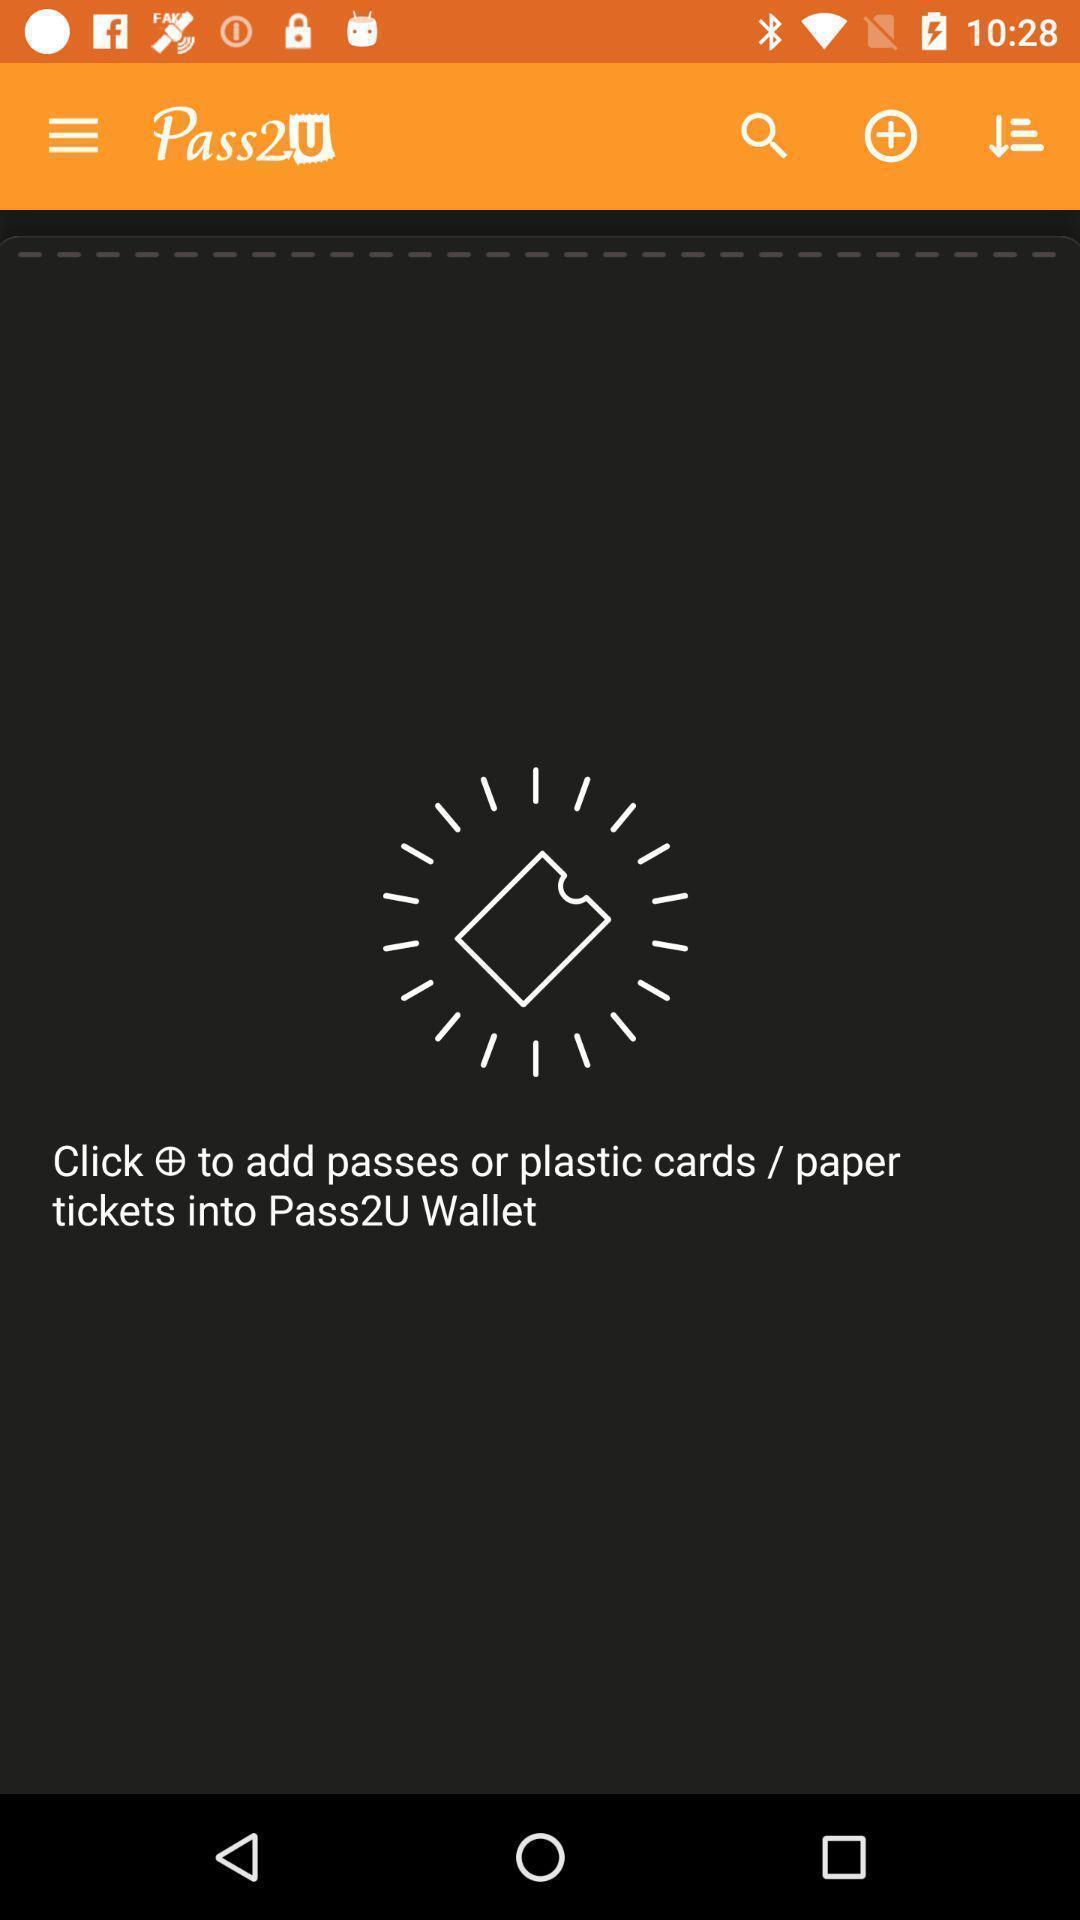What details can you identify in this image? Screen displaying the wallet page. 